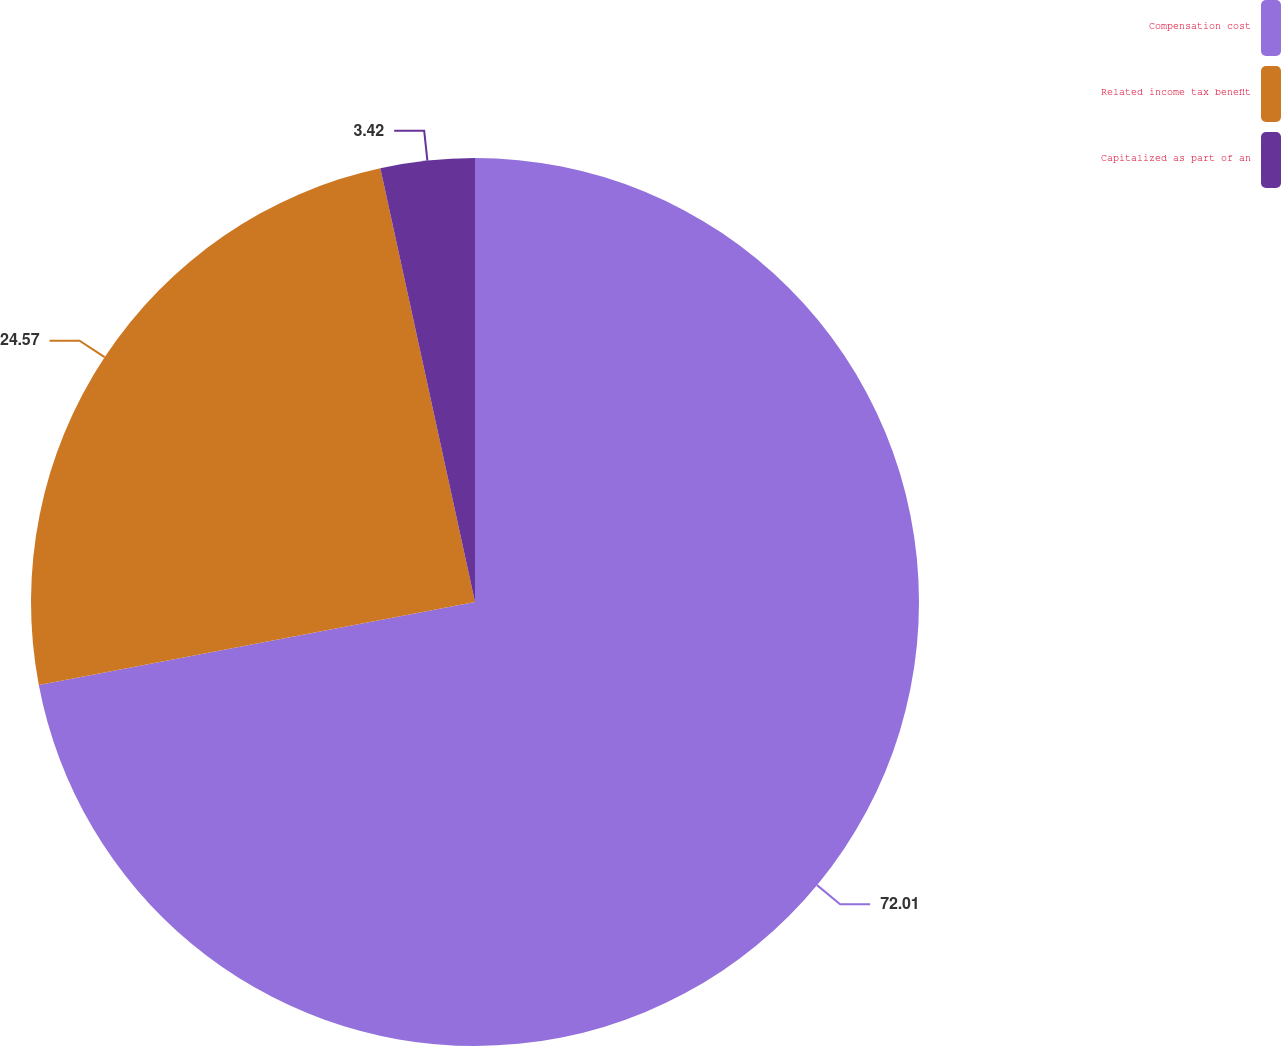<chart> <loc_0><loc_0><loc_500><loc_500><pie_chart><fcel>Compensation cost<fcel>Related income tax benefit<fcel>Capitalized as part of an<nl><fcel>72.01%<fcel>24.57%<fcel>3.42%<nl></chart> 